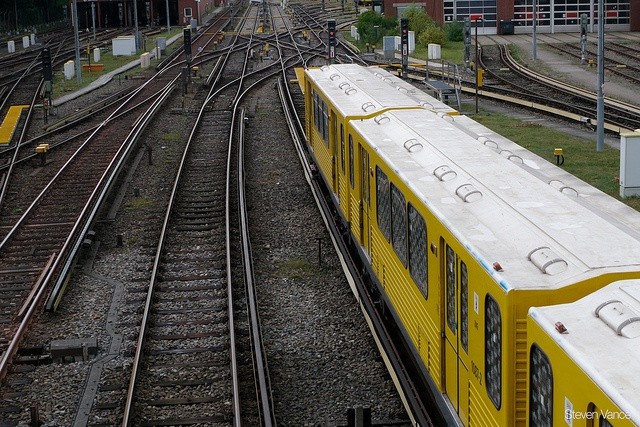Describe the objects in this image and their specific colors. I can see train in black, lightgray, and olive tones, traffic light in black, gray, and blue tones, traffic light in black, gray, and blue tones, traffic light in black, gray, and blue tones, and traffic light in black, gray, and purple tones in this image. 